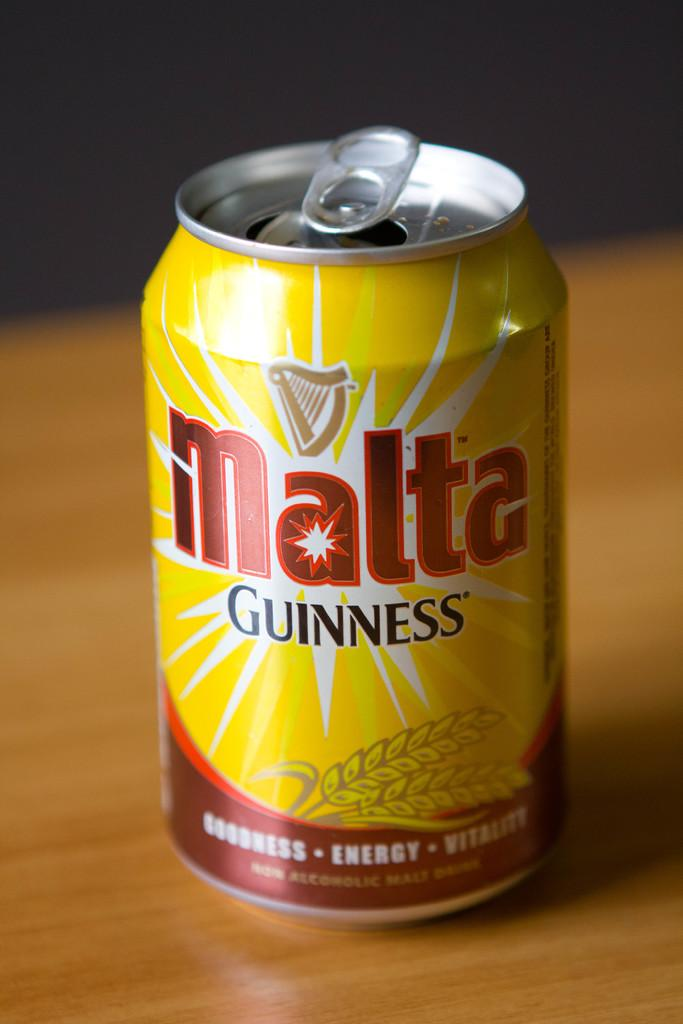<image>
Describe the image concisely. A yellow and brown can of Malta Guinness. 